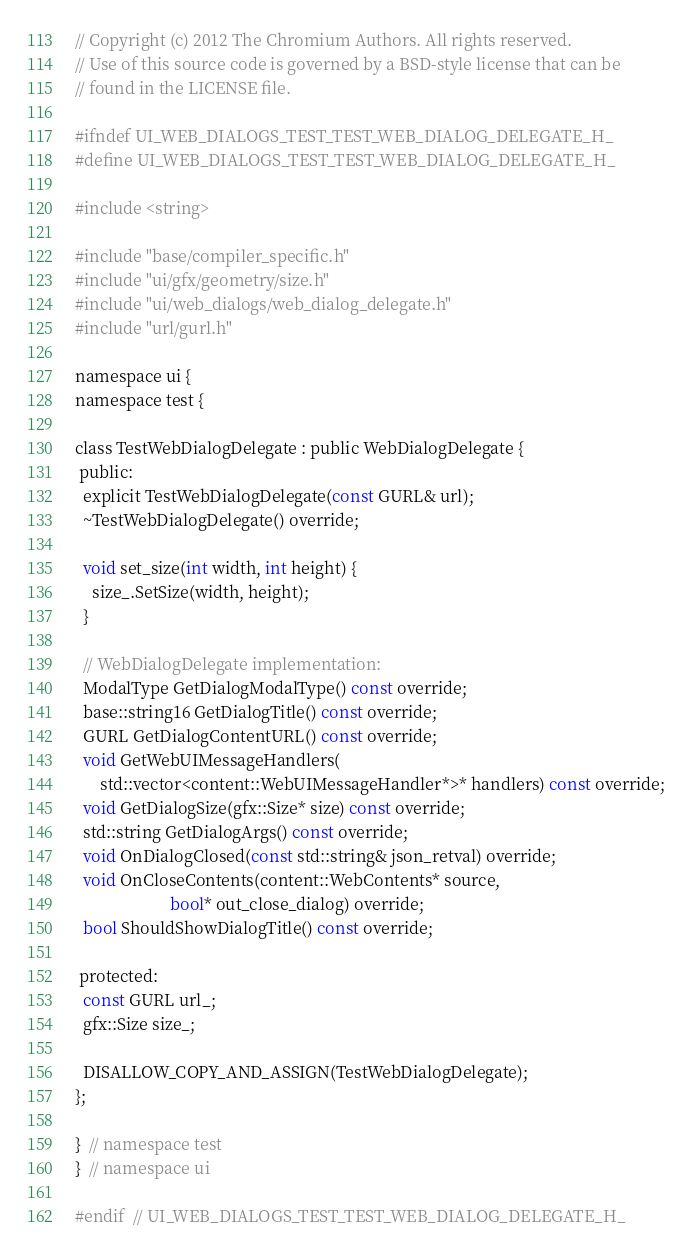Convert code to text. <code><loc_0><loc_0><loc_500><loc_500><_C_>// Copyright (c) 2012 The Chromium Authors. All rights reserved.
// Use of this source code is governed by a BSD-style license that can be
// found in the LICENSE file.

#ifndef UI_WEB_DIALOGS_TEST_TEST_WEB_DIALOG_DELEGATE_H_
#define UI_WEB_DIALOGS_TEST_TEST_WEB_DIALOG_DELEGATE_H_

#include <string>

#include "base/compiler_specific.h"
#include "ui/gfx/geometry/size.h"
#include "ui/web_dialogs/web_dialog_delegate.h"
#include "url/gurl.h"

namespace ui {
namespace test {

class TestWebDialogDelegate : public WebDialogDelegate {
 public:
  explicit TestWebDialogDelegate(const GURL& url);
  ~TestWebDialogDelegate() override;

  void set_size(int width, int height) {
    size_.SetSize(width, height);
  }

  // WebDialogDelegate implementation:
  ModalType GetDialogModalType() const override;
  base::string16 GetDialogTitle() const override;
  GURL GetDialogContentURL() const override;
  void GetWebUIMessageHandlers(
      std::vector<content::WebUIMessageHandler*>* handlers) const override;
  void GetDialogSize(gfx::Size* size) const override;
  std::string GetDialogArgs() const override;
  void OnDialogClosed(const std::string& json_retval) override;
  void OnCloseContents(content::WebContents* source,
                       bool* out_close_dialog) override;
  bool ShouldShowDialogTitle() const override;

 protected:
  const GURL url_;
  gfx::Size size_;

  DISALLOW_COPY_AND_ASSIGN(TestWebDialogDelegate);
};

}  // namespace test
}  // namespace ui

#endif  // UI_WEB_DIALOGS_TEST_TEST_WEB_DIALOG_DELEGATE_H_
</code> 